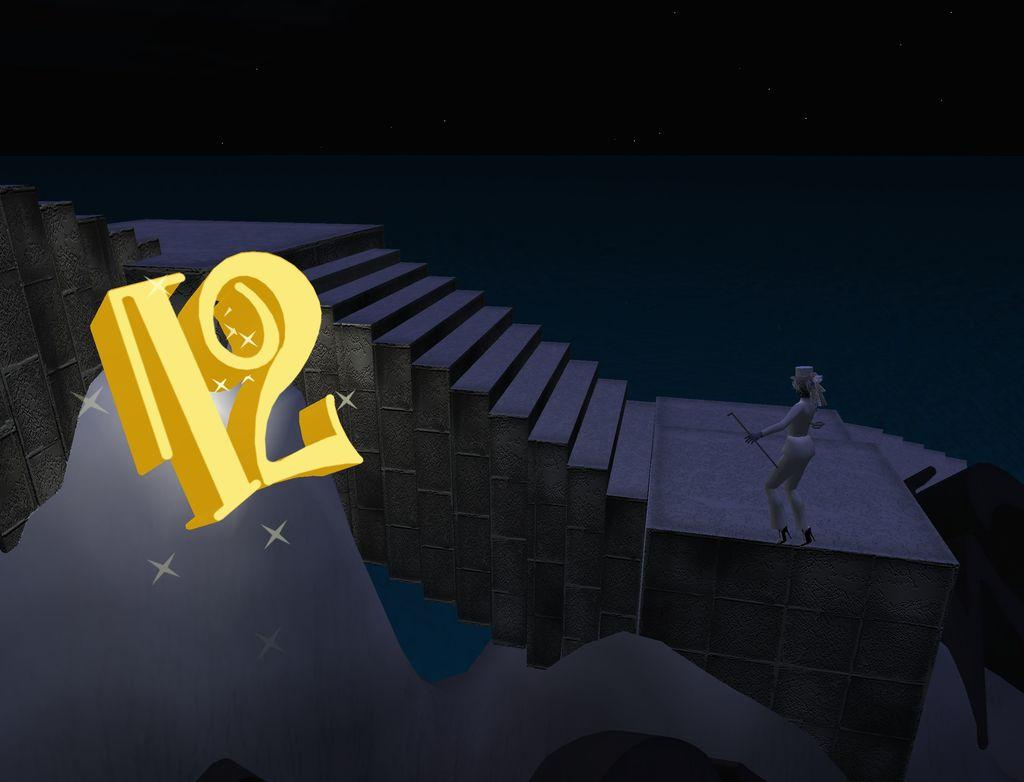How was the image altered or modified? The image is edited. What is the person in the image holding? The person is holding a stick in the image. What architectural feature is visible in front of the person? There are stairs in front of the person. What can be seen on the left side of the image? There are numbers on the left side of the image. What direction is the person facing in the image? The direction the person is facing cannot be determined from the image, as there is no reference point for north or any other direction. 